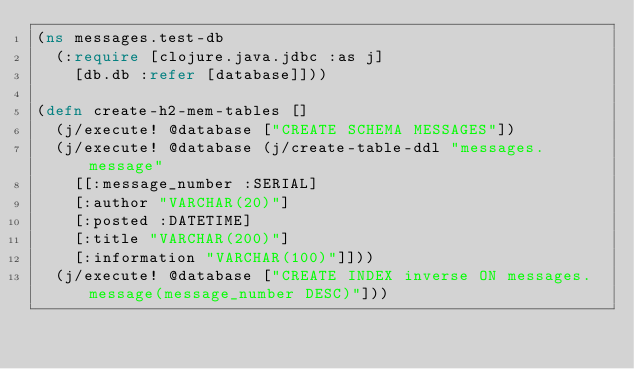<code> <loc_0><loc_0><loc_500><loc_500><_Clojure_>(ns messages.test-db
  (:require [clojure.java.jdbc :as j]
    [db.db :refer [database]]))

(defn create-h2-mem-tables []
  (j/execute! @database ["CREATE SCHEMA MESSAGES"])
  (j/execute! @database (j/create-table-ddl "messages.message"
    [[:message_number :SERIAL]
    [:author "VARCHAR(20)"]
    [:posted :DATETIME]
    [:title "VARCHAR(200)"]
    [:information "VARCHAR(100)"]]))
  (j/execute! @database ["CREATE INDEX inverse ON messages.message(message_number DESC)"]))
</code> 